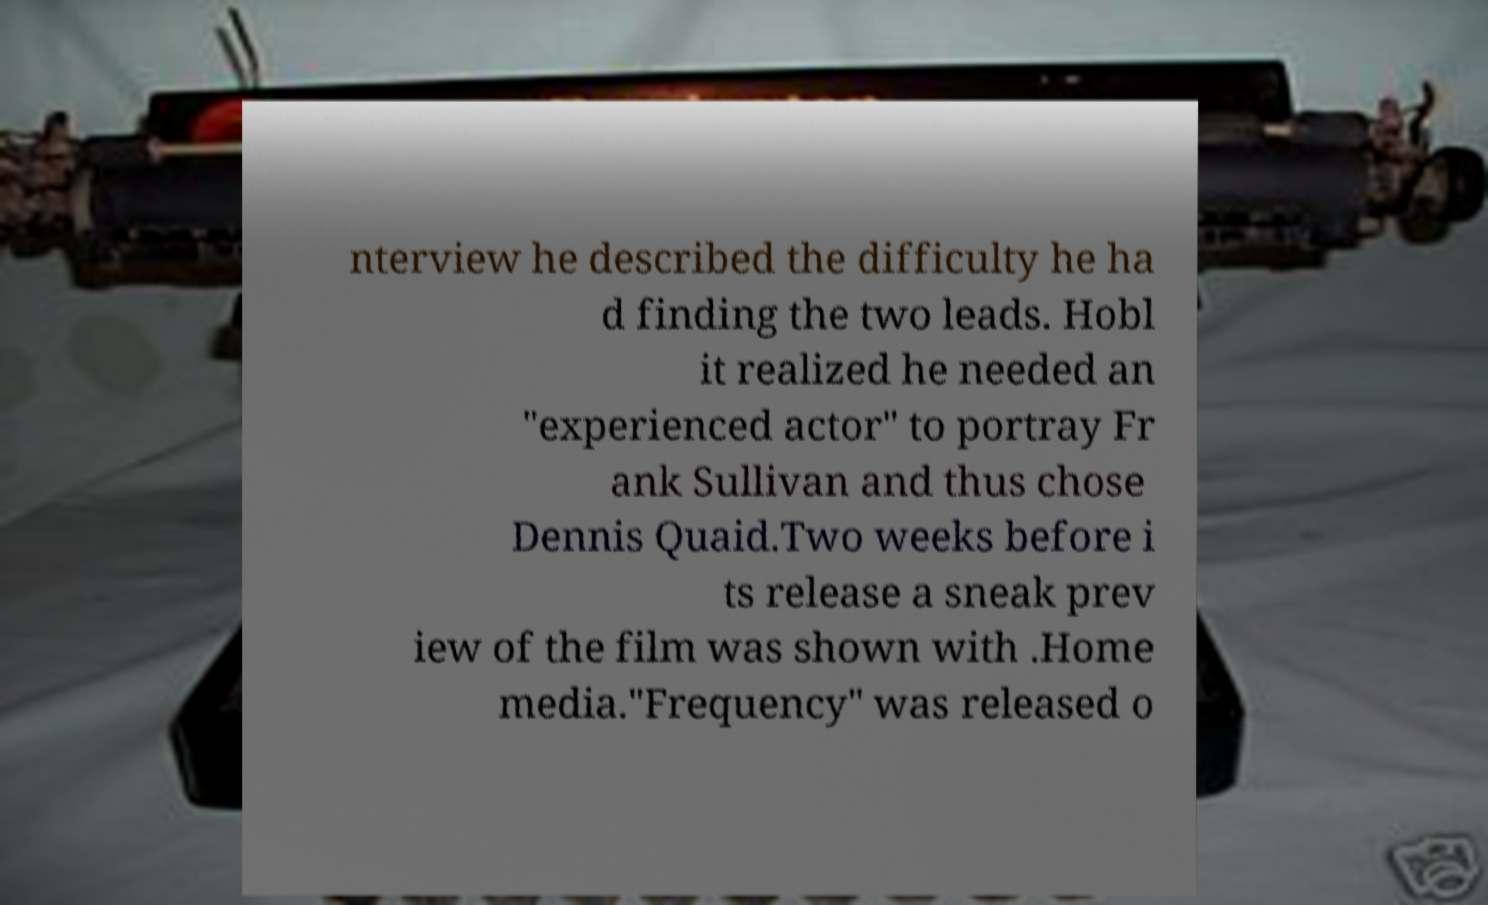Can you read and provide the text displayed in the image?This photo seems to have some interesting text. Can you extract and type it out for me? nterview he described the difficulty he ha d finding the two leads. Hobl it realized he needed an "experienced actor" to portray Fr ank Sullivan and thus chose Dennis Quaid.Two weeks before i ts release a sneak prev iew of the film was shown with .Home media."Frequency" was released o 